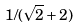Convert formula to latex. <formula><loc_0><loc_0><loc_500><loc_500>1 / ( \sqrt { 2 } + 2 )</formula> 